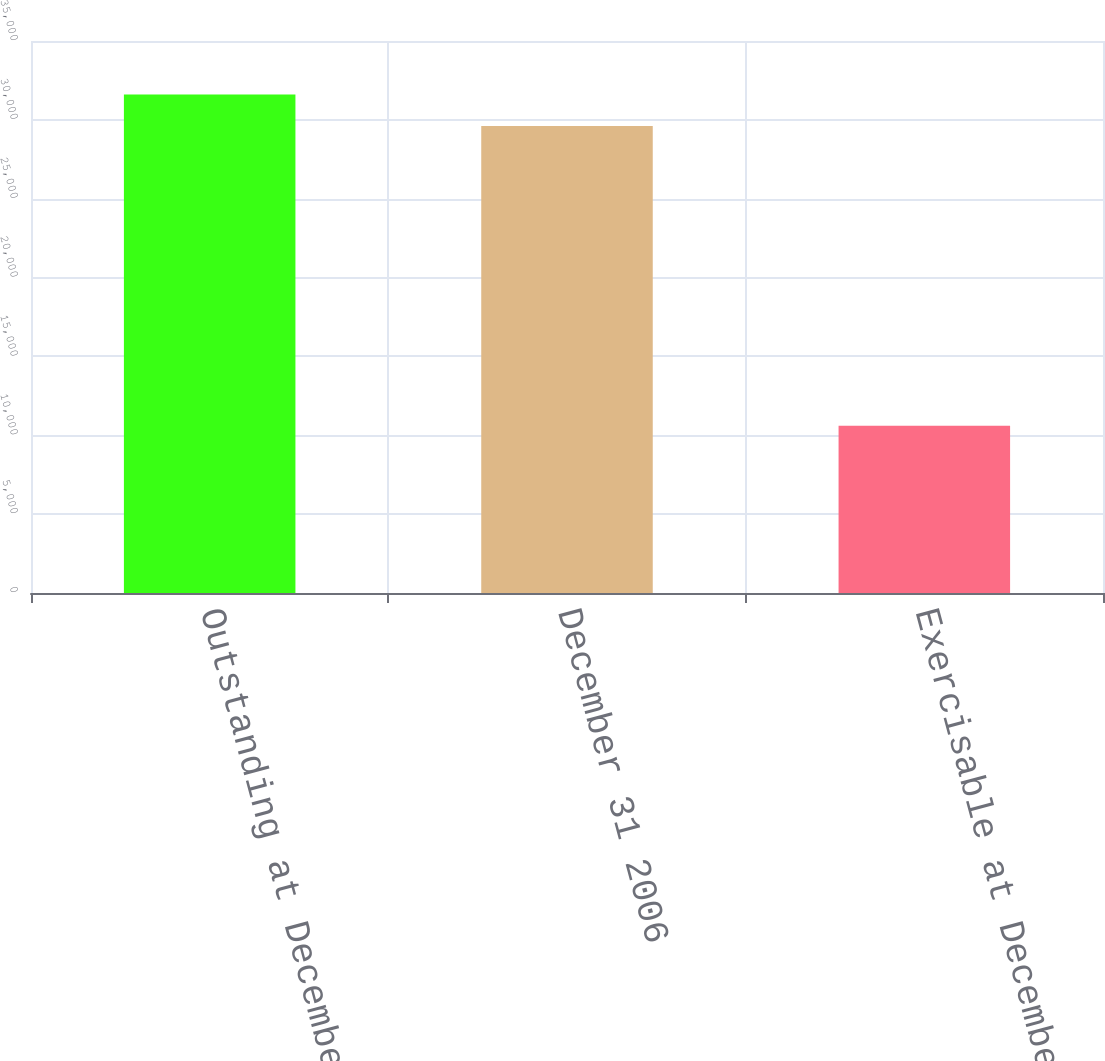Convert chart to OTSL. <chart><loc_0><loc_0><loc_500><loc_500><bar_chart><fcel>Outstanding at December 31<fcel>December 31 2006<fcel>Exercisable at December 31<nl><fcel>31608<fcel>29615<fcel>10602<nl></chart> 